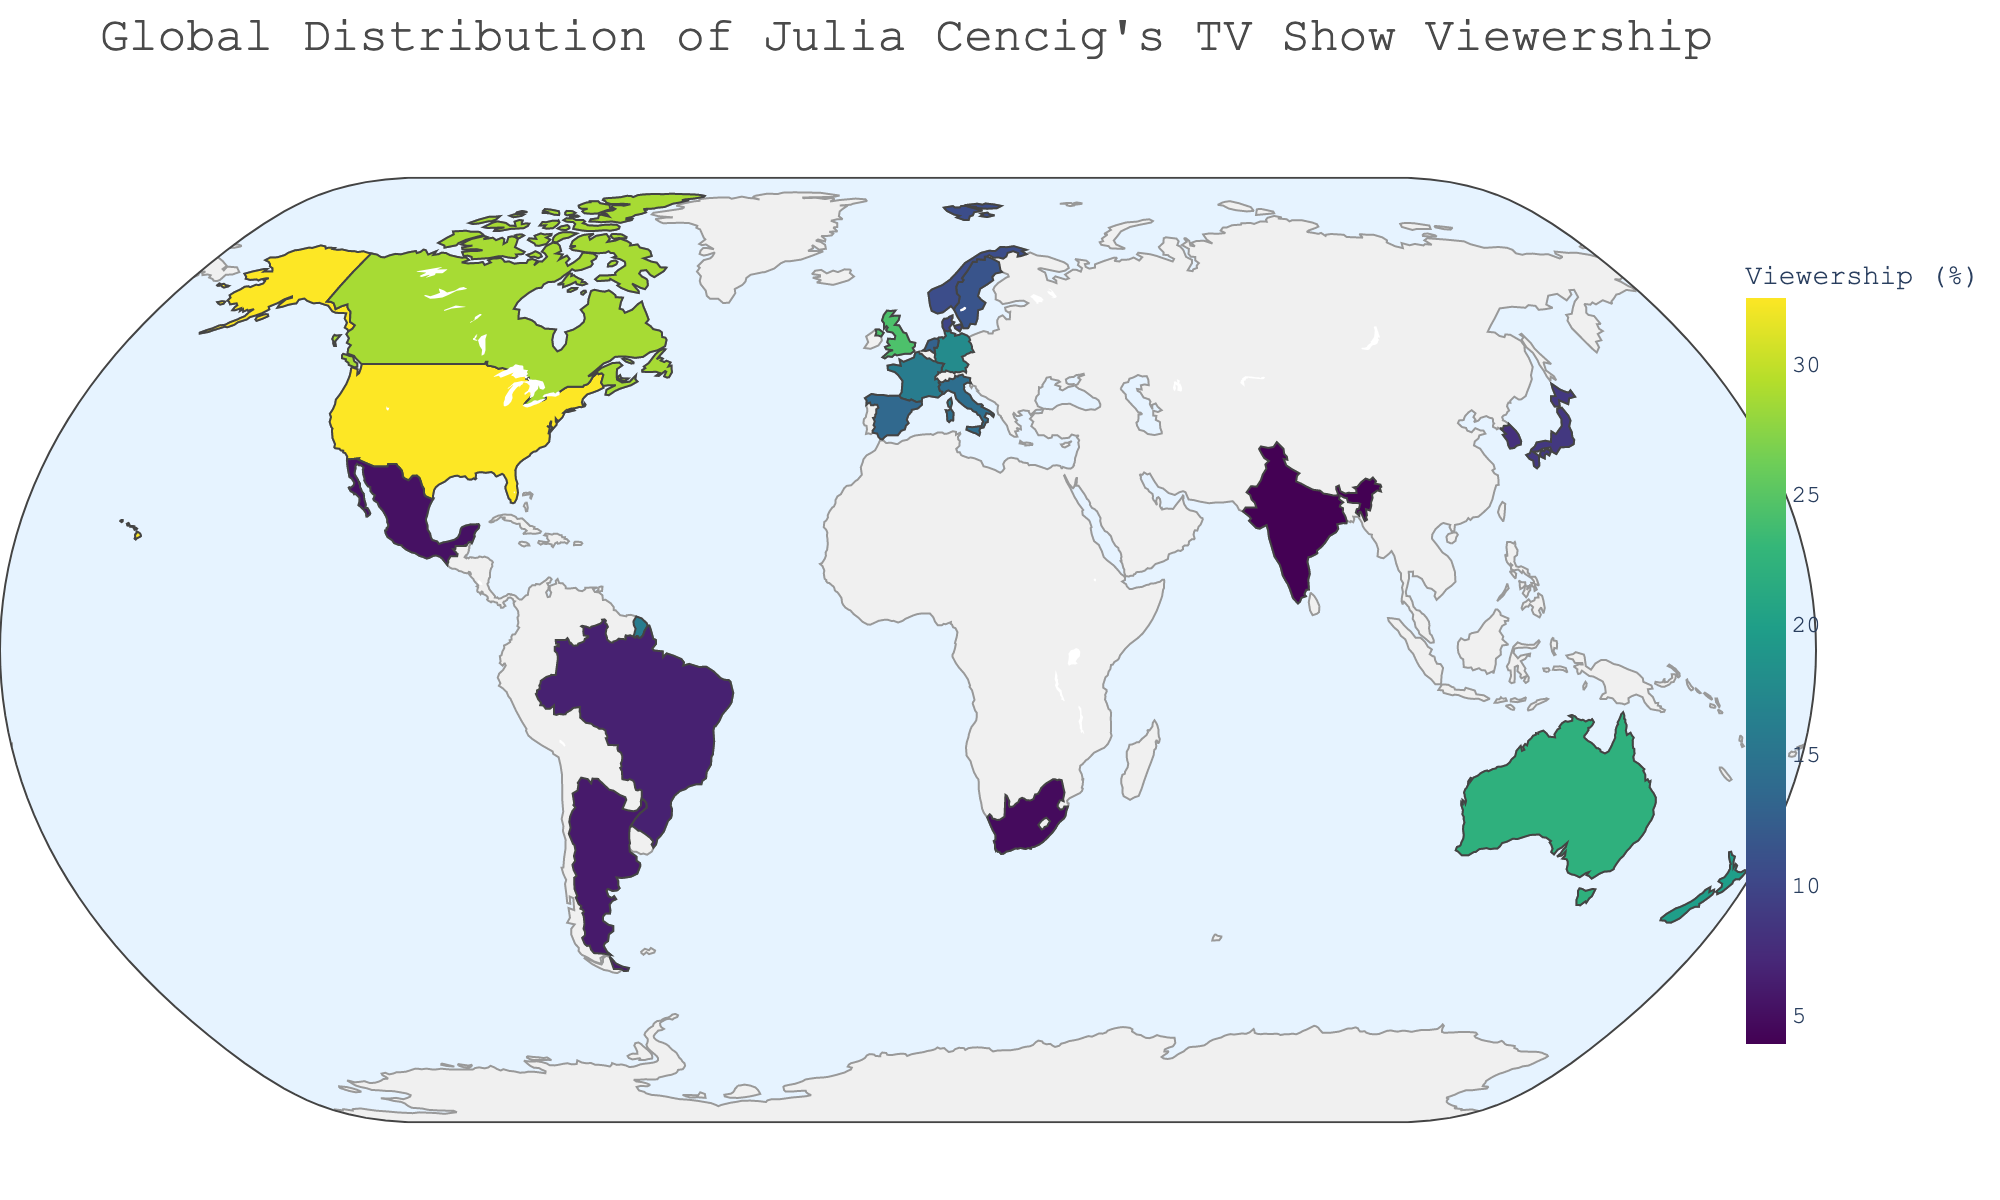Which country has the highest viewership percentage? To find the country with the highest viewership percentage, look for the highest value in the color scale, which corresponds to the darkest shade on the map. According to the data, the United States has the highest viewership percentage.
Answer: United States What is the difference in viewership percentage between Canada and Germany? First, identify the viewership percentages of Canada (28.7) and Germany (17.6) from the data. Then, subtract Germany’s percentage from Canada’s percentage: 28.7 - 17.6 = 11.1.
Answer: 11.1 Which countries have a viewership percentage greater than 20%? Examine the countries on the map with darker shades corresponding to higher viewership percentages. From the data, the countries with viewership percentages greater than 20% are the United States, Canada, United Kingdom, and Australia.
Answer: United States, Canada, United Kingdom, Australia What is the average viewership percentage of the top 5 countries? From the data, the top 5 countries by viewership percentage are the United States (32.5), Canada (28.7), United Kingdom (24.3), Australia (22.1), and New Zealand (19.8). Sum these percentages: 32.5 + 28.7 + 24.3 + 22.1 + 19.8 = 127.4, then divide by 5: 127.4 ÷ 5 = 25.48.
Answer: 25.48 Compare the viewership percentages between Italy and Spain. Which country has a higher percentage? Refer to the data to find the viewership percentages for Italy (14.2) and Spain (13.5). Italy’s viewership percentage is higher.
Answer: Italy Which geographic regions show lower viewership percentages, below 10%? Identify regions on the map that have lighter shades representing lower viewership percentages. From the data, the countries with percentages below 10% are Denmark, Japan, South Korea, Brazil, Argentina, Mexico, South Africa, and India.
Answer: Denmark, Japan, South Korea, Brazil, Argentina, Mexico, South Africa, India What is the total viewership percentage of all European countries listed in the data? Sum the viewership percentages of the European countries: United Kingdom (24.3), Germany (17.6), France (15.9), Italy (14.2), Spain (13.5), and Netherlands (12.8), Sweden (11.4), Norway (10.7), Denmark (9.9). This gives 24.3 + 17.6 + 15.9 + 14.2 + 13.5 + 12.8 + 11.4 + 10.7 + 9.9 = 130.3.
Answer: 130.3 